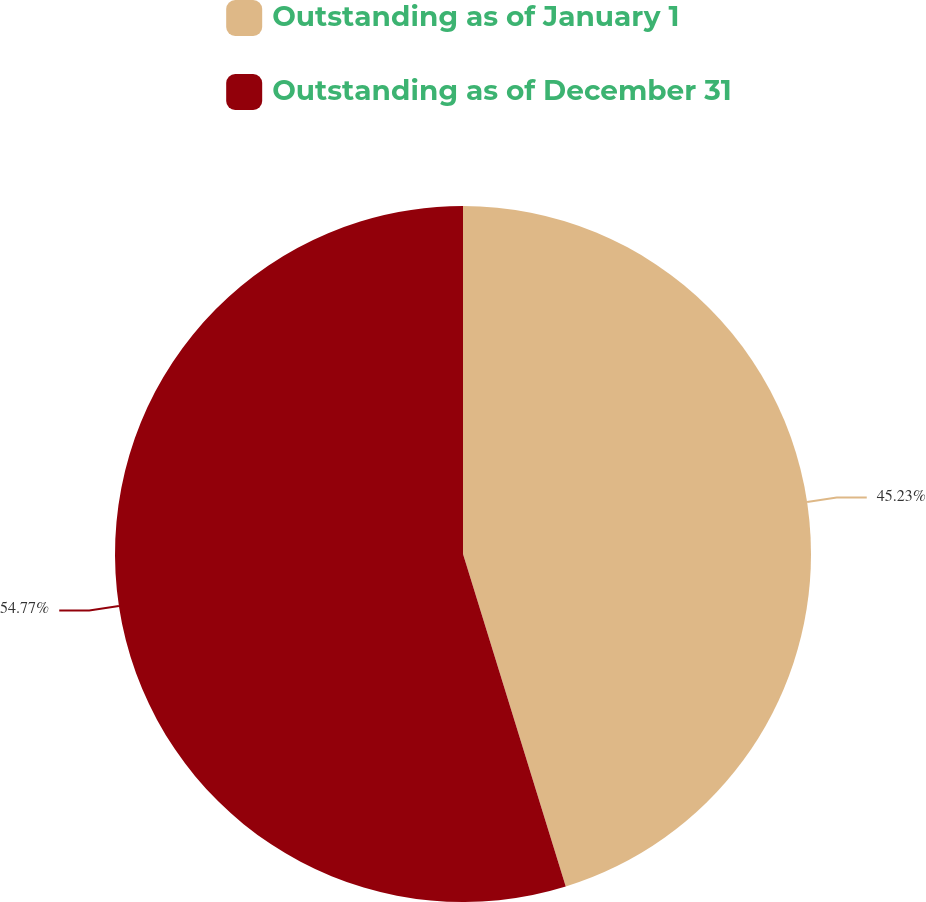<chart> <loc_0><loc_0><loc_500><loc_500><pie_chart><fcel>Outstanding as of January 1<fcel>Outstanding as of December 31<nl><fcel>45.23%<fcel>54.77%<nl></chart> 